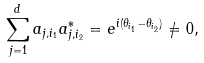<formula> <loc_0><loc_0><loc_500><loc_500>\sum _ { j = 1 } ^ { d } a _ { j , i _ { 1 } } a _ { j , i _ { 2 } } ^ { * } = e ^ { i ( \theta _ { i _ { 1 } } - \theta _ { i _ { 2 } } ) } \not = 0 ,</formula> 